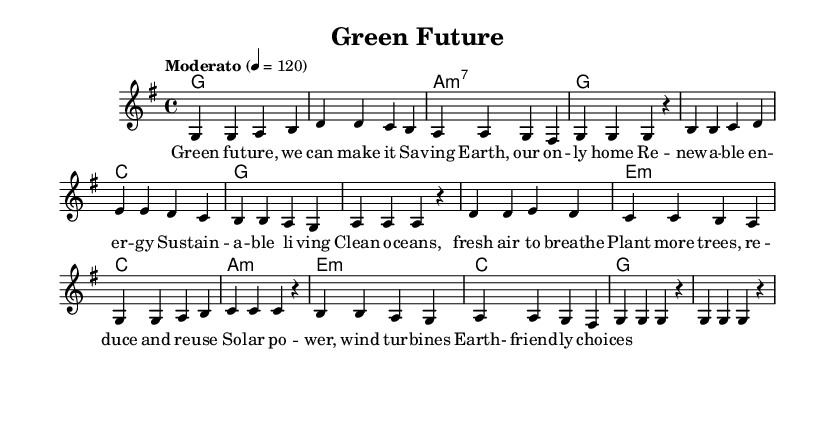What is the key signature of this music? The key signature is G major, indicated by one sharp (F#).
Answer: G major What is the time signature of this music? The time signature is 4/4, which means there are four beats in each measure and the quarter note gets one beat.
Answer: 4/4 What is the tempo of this piece? The tempo marking indicates a "Moderato" tempo at 120 beats per minute.
Answer: Moderato How many measures are in the melody? By counting the individual measures in the melody section, there are a total of 16 measures.
Answer: 16 What is the first lyric line of the song? The first lyric line, as indicated in the verse section, is "Green fu -- ture, we can make it".
Answer: Green fu -- ture, we can make it Are there any harmony changes in the score? Yes, the harmony changes occur in a regular pattern throughout the piece, corresponding with the melody. The chord changes are specifically marked above the melody.
Answer: Yes What themes does the song focus on based on the lyrics? The lyrics focus on themes of environmental conservation and sustainable living, as highlighted by phrases like “Saving Earth” and “Renewable energy.”
Answer: Environmental conservation 